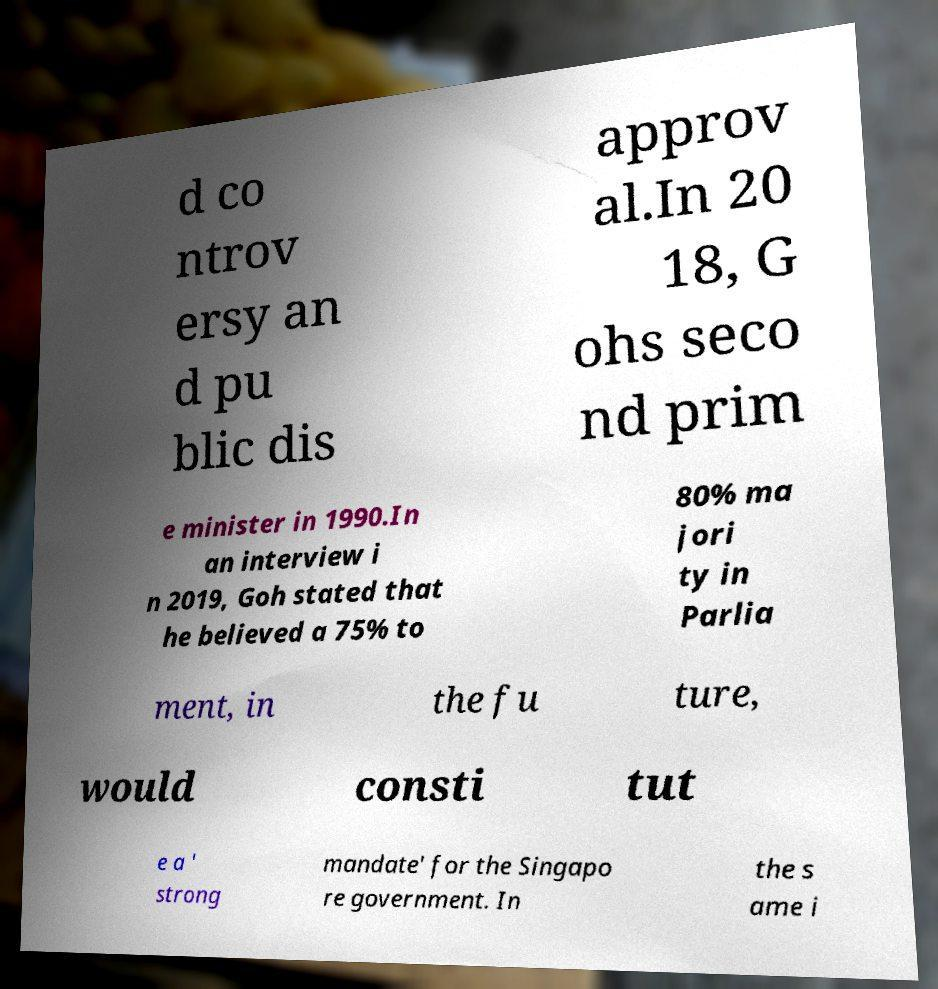Can you read and provide the text displayed in the image?This photo seems to have some interesting text. Can you extract and type it out for me? d co ntrov ersy an d pu blic dis approv al.In 20 18, G ohs seco nd prim e minister in 1990.In an interview i n 2019, Goh stated that he believed a 75% to 80% ma jori ty in Parlia ment, in the fu ture, would consti tut e a ' strong mandate' for the Singapo re government. In the s ame i 